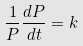Convert formula to latex. <formula><loc_0><loc_0><loc_500><loc_500>\frac { 1 } { P } \frac { d P } { d t } = k</formula> 